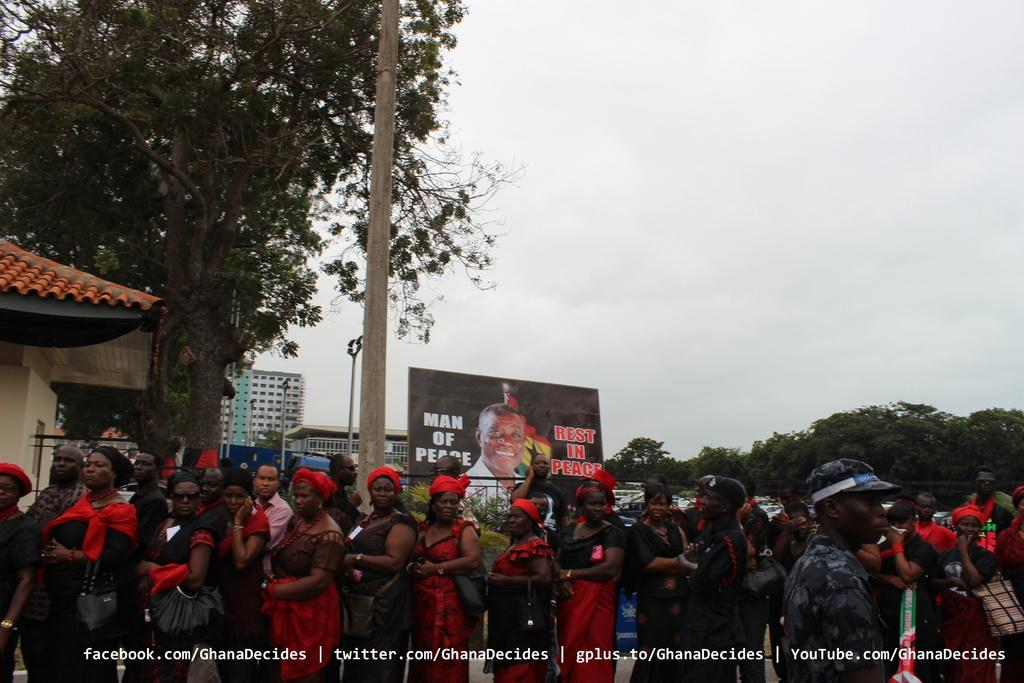How many people are in the image? There is a group of people in the image, but the exact number cannot be determined from the provided facts. What else can be seen on the ground in the image? There are vehicles on the ground in the image. What is in the background of the image? There is a banner and trees in the background of the image, as well as the sky. What type of cracker is being used to answer the questions in the image? There is no cracker present in the image, nor is there any indication that the people in the image are answering questions. 